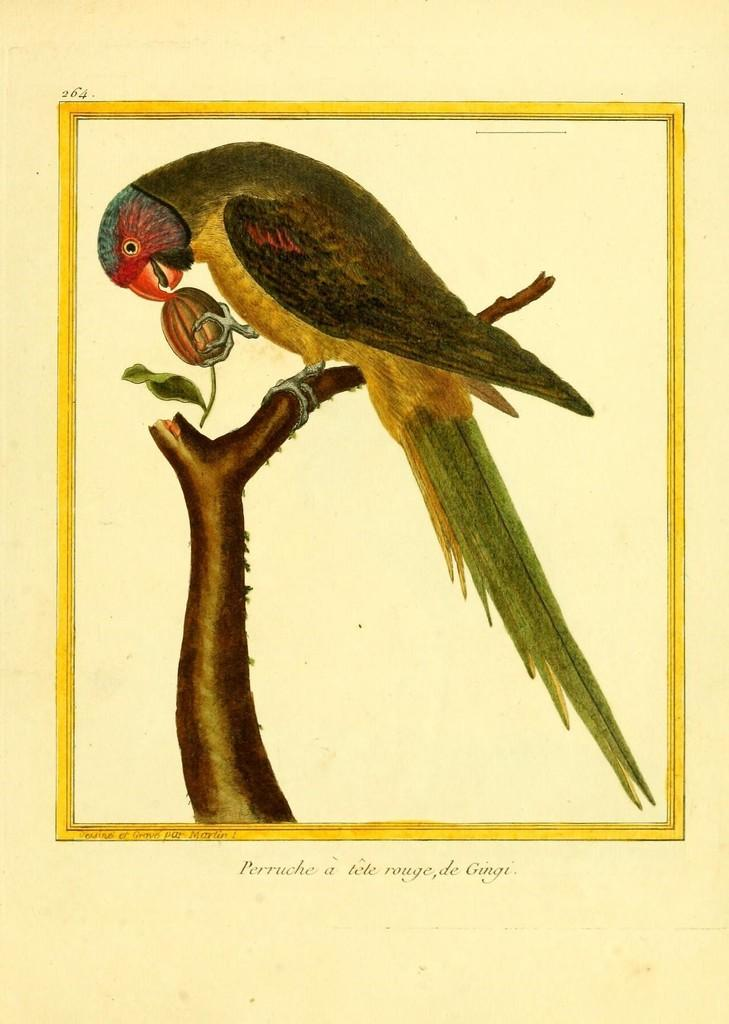What type of animal can be seen in the image? There is a bird in the image. Where is the bird located? The bird is standing on a stem in the image. What is the bird doing in the image? The bird is eating something in the image. What color is the background of the image? The background of the image is cream in color. What type of pen is the bird using to write in the image? There is no pen present in the image, and the bird is not writing. 